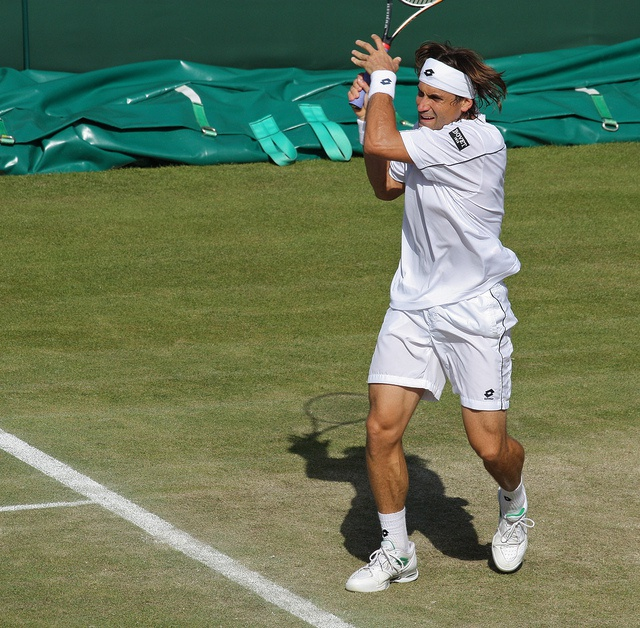Describe the objects in this image and their specific colors. I can see people in teal, lavender, darkgray, black, and salmon tones and tennis racket in teal, darkgreen, black, white, and gray tones in this image. 